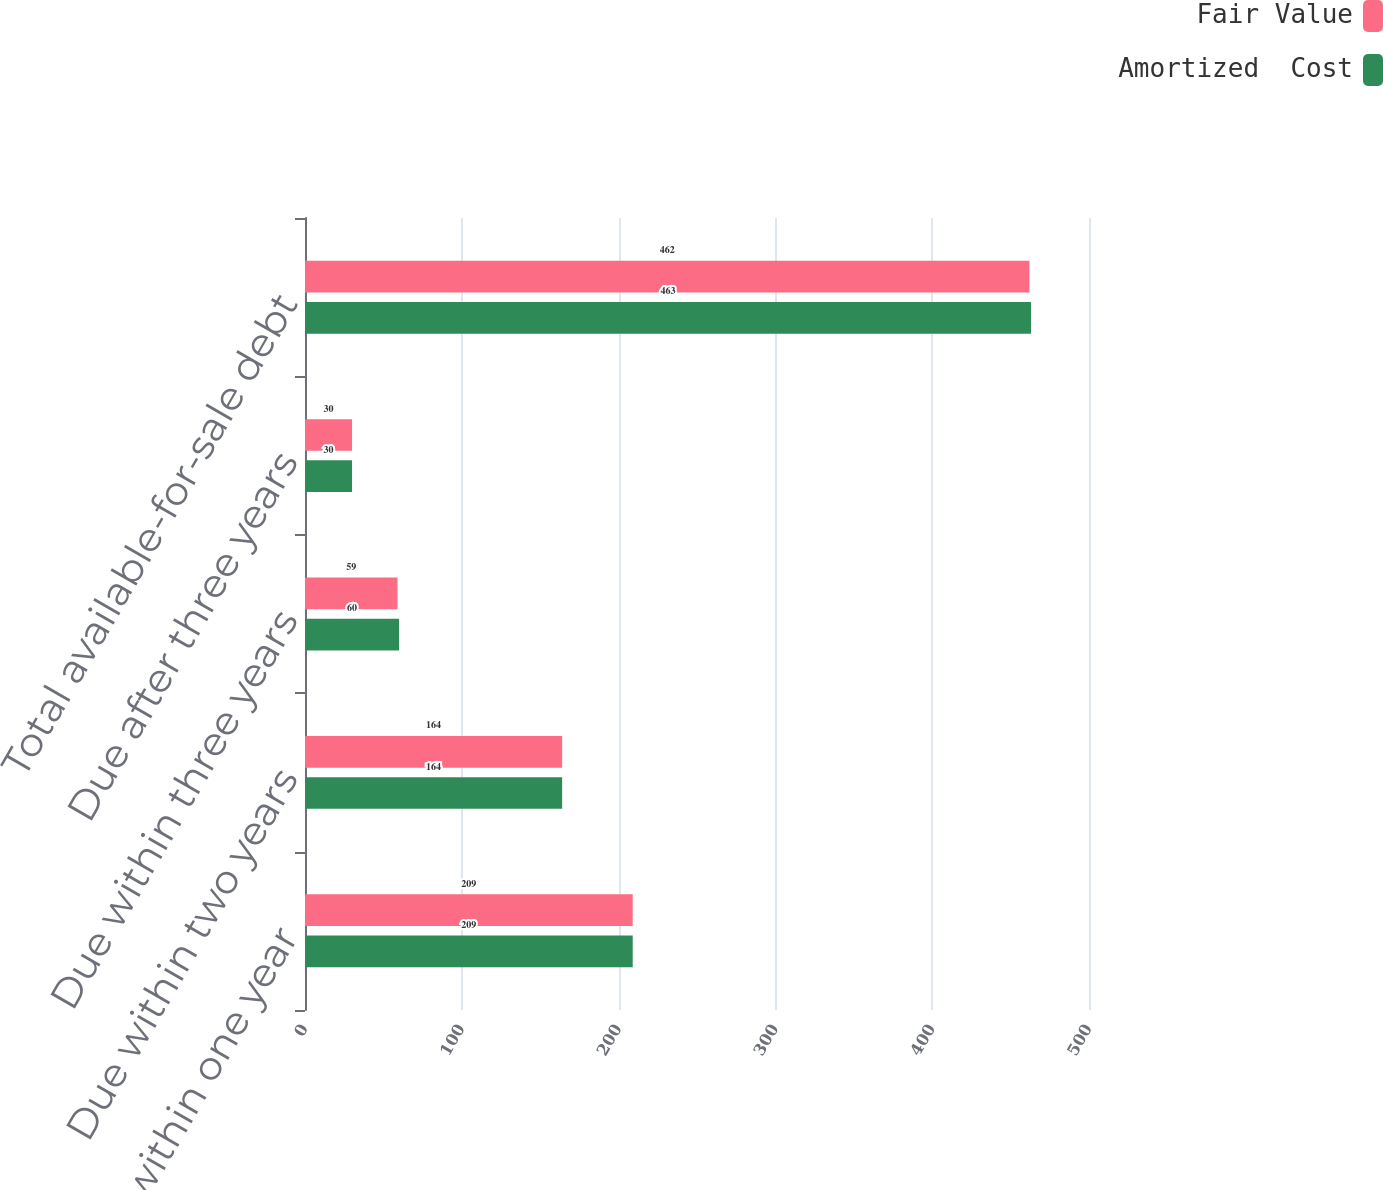Convert chart. <chart><loc_0><loc_0><loc_500><loc_500><stacked_bar_chart><ecel><fcel>Due within one year<fcel>Due within two years<fcel>Due within three years<fcel>Due after three years<fcel>Total available-for-sale debt<nl><fcel>Fair Value<fcel>209<fcel>164<fcel>59<fcel>30<fcel>462<nl><fcel>Amortized  Cost<fcel>209<fcel>164<fcel>60<fcel>30<fcel>463<nl></chart> 